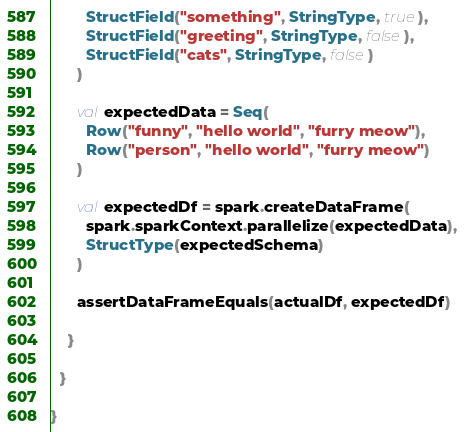Convert code to text. <code><loc_0><loc_0><loc_500><loc_500><_Scala_>        StructField("something", StringType, true),
        StructField("greeting", StringType, false),
        StructField("cats", StringType, false)
      )

      val expectedData = Seq(
        Row("funny", "hello world", "furry meow"),
        Row("person", "hello world", "furry meow")
      )

      val expectedDf = spark.createDataFrame(
        spark.sparkContext.parallelize(expectedData),
        StructType(expectedSchema)
      )

      assertDataFrameEquals(actualDf, expectedDf)

    }

  }

}
</code> 